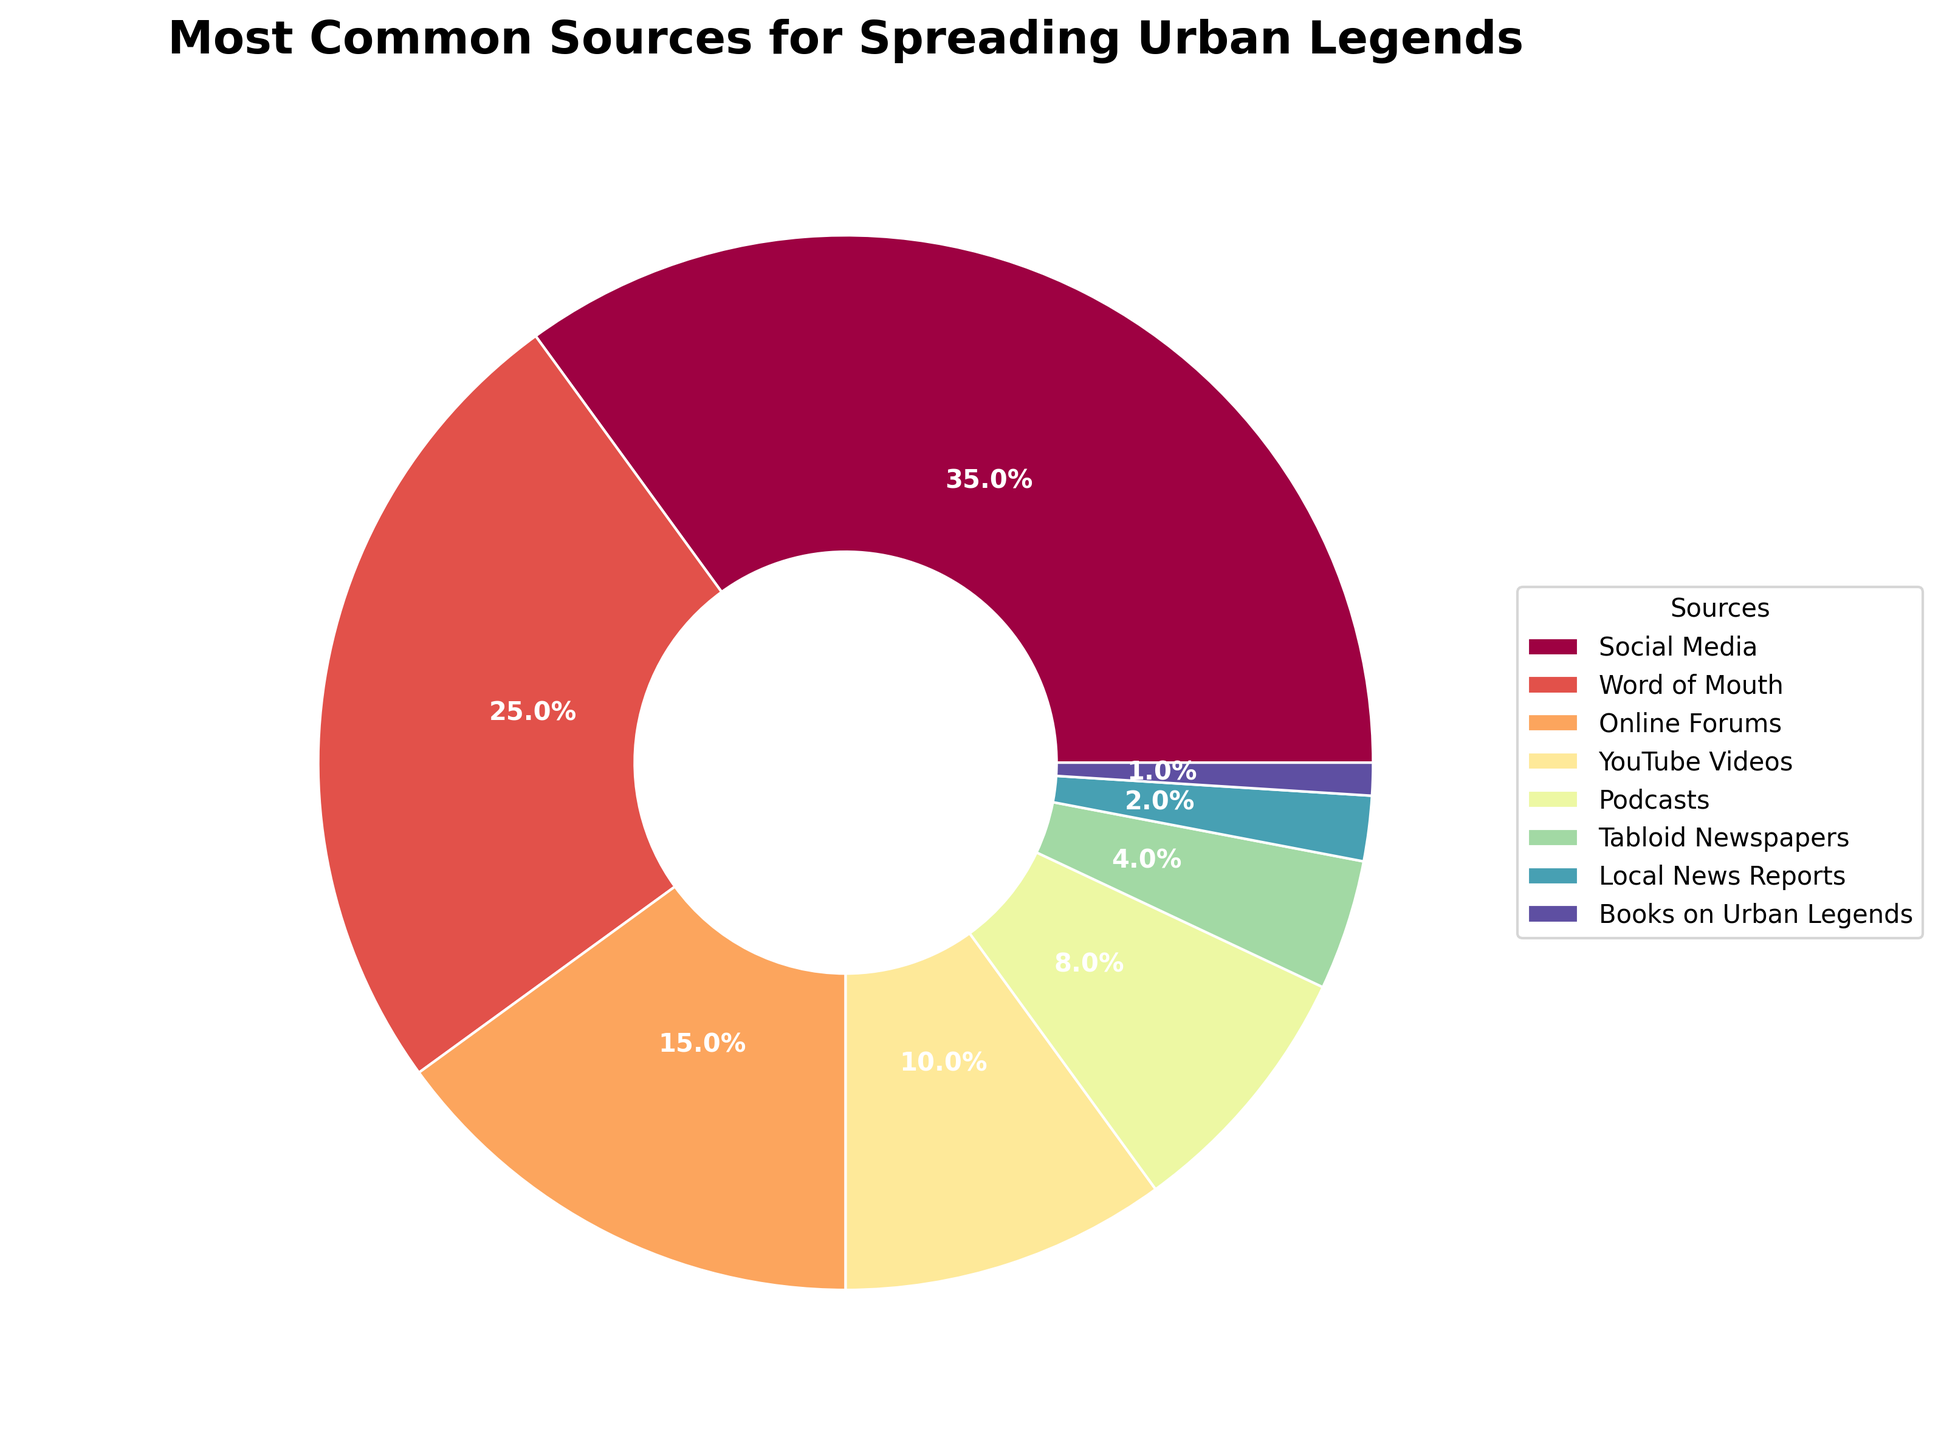Which source has the highest percentage of urban legend spreading? Observing the pie chart, the largest slice corresponds to "Social Media", which is 35%.
Answer: Social Media Which source has the smallest percentage? The smallest slice in the pie chart corresponds to "Books on Urban Legends", which is 1%.
Answer: Books on Urban Legends What is the combined percentage of urban legends spread through "Social Media" and "Word of Mouth"? The percentages for "Social Media" and "Word of Mouth" are 35% and 25%, respectively. Adding them together gives 35% + 25% = 60%.
Answer: 60% By how much does the percentage of urban legends spread through "Podcasts" exceed those spread through "Tabloid Newspapers"? The percentage for "Podcasts" is 8%, and for "Tabloid Newspapers" it is 4%. The difference is 8% - 4% = 4%.
Answer: 4% Which source has a percentage that is twice the percentage of those spread through "Tabloid Newspapers"? The percentage for "Tabloid Newspapers" is 4%. Double this amount is 4% × 2 = 8%. The source corresponding to this percentage is "Podcasts".
Answer: Podcasts What percentage of urban legends is spread through "Online Forums" relative to "YouTube Videos"? The percentage for "Online Forums" is 15%, while for "YouTube Videos" it is 10%. Dividing the former by the latter gives 15% ÷ 10% = 1.5, or 150%.
Answer: 150% How many sources have a percentage under 10%? Observing the pie chart, the sources with percentages under 10% are "YouTube Videos" (10%), "Podcasts" (8%), "Tabloid Newspapers" (4%), "Local News Reports" (2%), and "Books on Urban Legends" (1%). There are 5 such sources.
Answer: 5 What is the total percentage covered by "YouTube Videos", "Podcasts", and "Books on Urban Legends"? Adding the percentages of "YouTube Videos" (10%), "Podcasts" (8%), and "Books on Urban Legends" (1%) gives 10% + 8% + 1% = 19%.
Answer: 19% Which has a higher percentage, “Online Forums” or “Local News Reports”? "Online Forums" have a percentage of 15%, while "Local News Reports" have a percentage of 2%. Therefore, "Online Forums" have a higher percentage.
Answer: Online Forums 